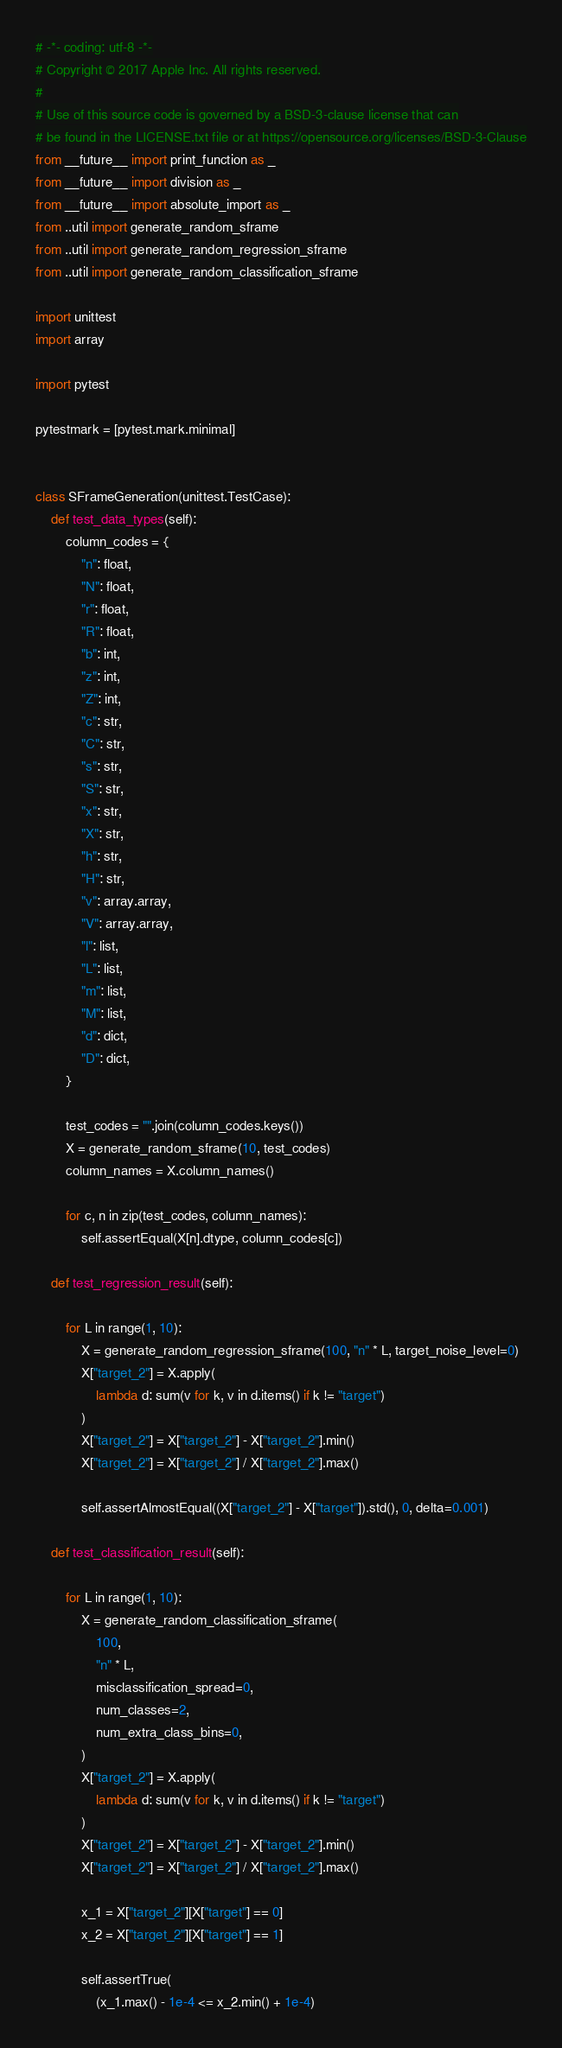<code> <loc_0><loc_0><loc_500><loc_500><_Python_># -*- coding: utf-8 -*-
# Copyright © 2017 Apple Inc. All rights reserved.
#
# Use of this source code is governed by a BSD-3-clause license that can
# be found in the LICENSE.txt file or at https://opensource.org/licenses/BSD-3-Clause
from __future__ import print_function as _
from __future__ import division as _
from __future__ import absolute_import as _
from ..util import generate_random_sframe
from ..util import generate_random_regression_sframe
from ..util import generate_random_classification_sframe

import unittest
import array

import pytest

pytestmark = [pytest.mark.minimal]


class SFrameGeneration(unittest.TestCase):
    def test_data_types(self):
        column_codes = {
            "n": float,
            "N": float,
            "r": float,
            "R": float,
            "b": int,
            "z": int,
            "Z": int,
            "c": str,
            "C": str,
            "s": str,
            "S": str,
            "x": str,
            "X": str,
            "h": str,
            "H": str,
            "v": array.array,
            "V": array.array,
            "l": list,
            "L": list,
            "m": list,
            "M": list,
            "d": dict,
            "D": dict,
        }

        test_codes = "".join(column_codes.keys())
        X = generate_random_sframe(10, test_codes)
        column_names = X.column_names()

        for c, n in zip(test_codes, column_names):
            self.assertEqual(X[n].dtype, column_codes[c])

    def test_regression_result(self):

        for L in range(1, 10):
            X = generate_random_regression_sframe(100, "n" * L, target_noise_level=0)
            X["target_2"] = X.apply(
                lambda d: sum(v for k, v in d.items() if k != "target")
            )
            X["target_2"] = X["target_2"] - X["target_2"].min()
            X["target_2"] = X["target_2"] / X["target_2"].max()

            self.assertAlmostEqual((X["target_2"] - X["target"]).std(), 0, delta=0.001)

    def test_classification_result(self):

        for L in range(1, 10):
            X = generate_random_classification_sframe(
                100,
                "n" * L,
                misclassification_spread=0,
                num_classes=2,
                num_extra_class_bins=0,
            )
            X["target_2"] = X.apply(
                lambda d: sum(v for k, v in d.items() if k != "target")
            )
            X["target_2"] = X["target_2"] - X["target_2"].min()
            X["target_2"] = X["target_2"] / X["target_2"].max()

            x_1 = X["target_2"][X["target"] == 0]
            x_2 = X["target_2"][X["target"] == 1]

            self.assertTrue(
                (x_1.max() - 1e-4 <= x_2.min() + 1e-4)</code> 